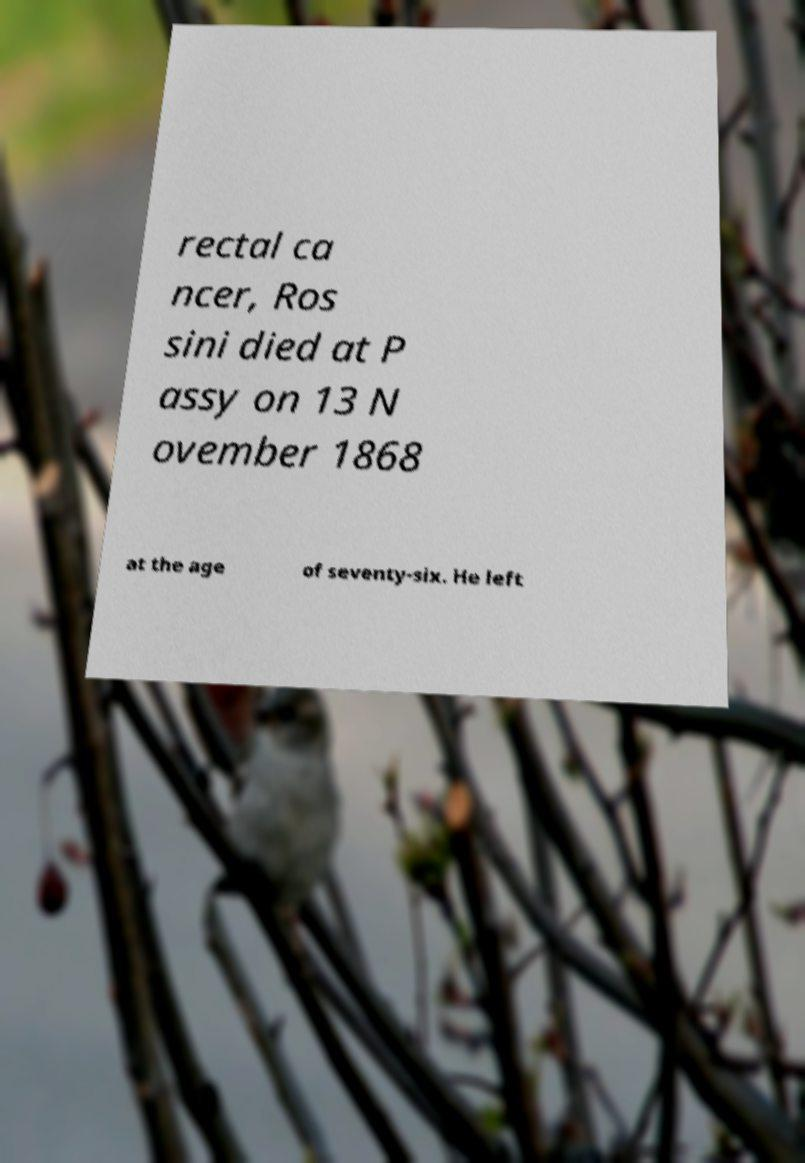Please read and relay the text visible in this image. What does it say? rectal ca ncer, Ros sini died at P assy on 13 N ovember 1868 at the age of seventy-six. He left 